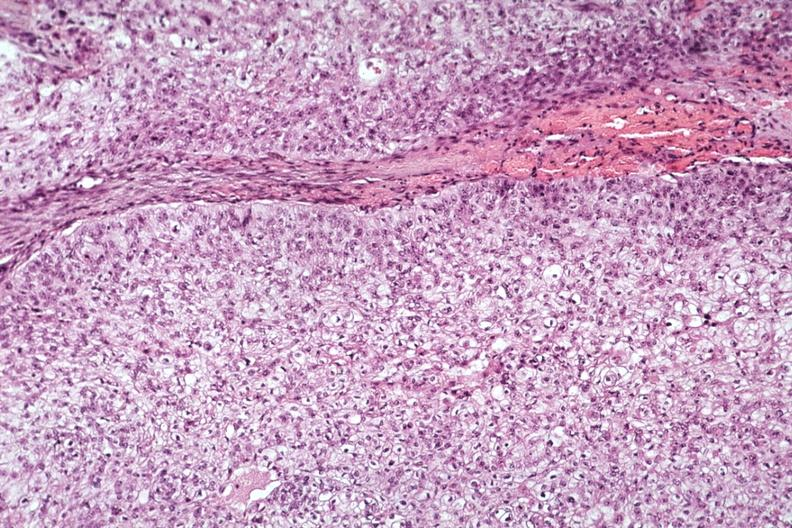does this image show good photo of tumor cells?
Answer the question using a single word or phrase. Yes 